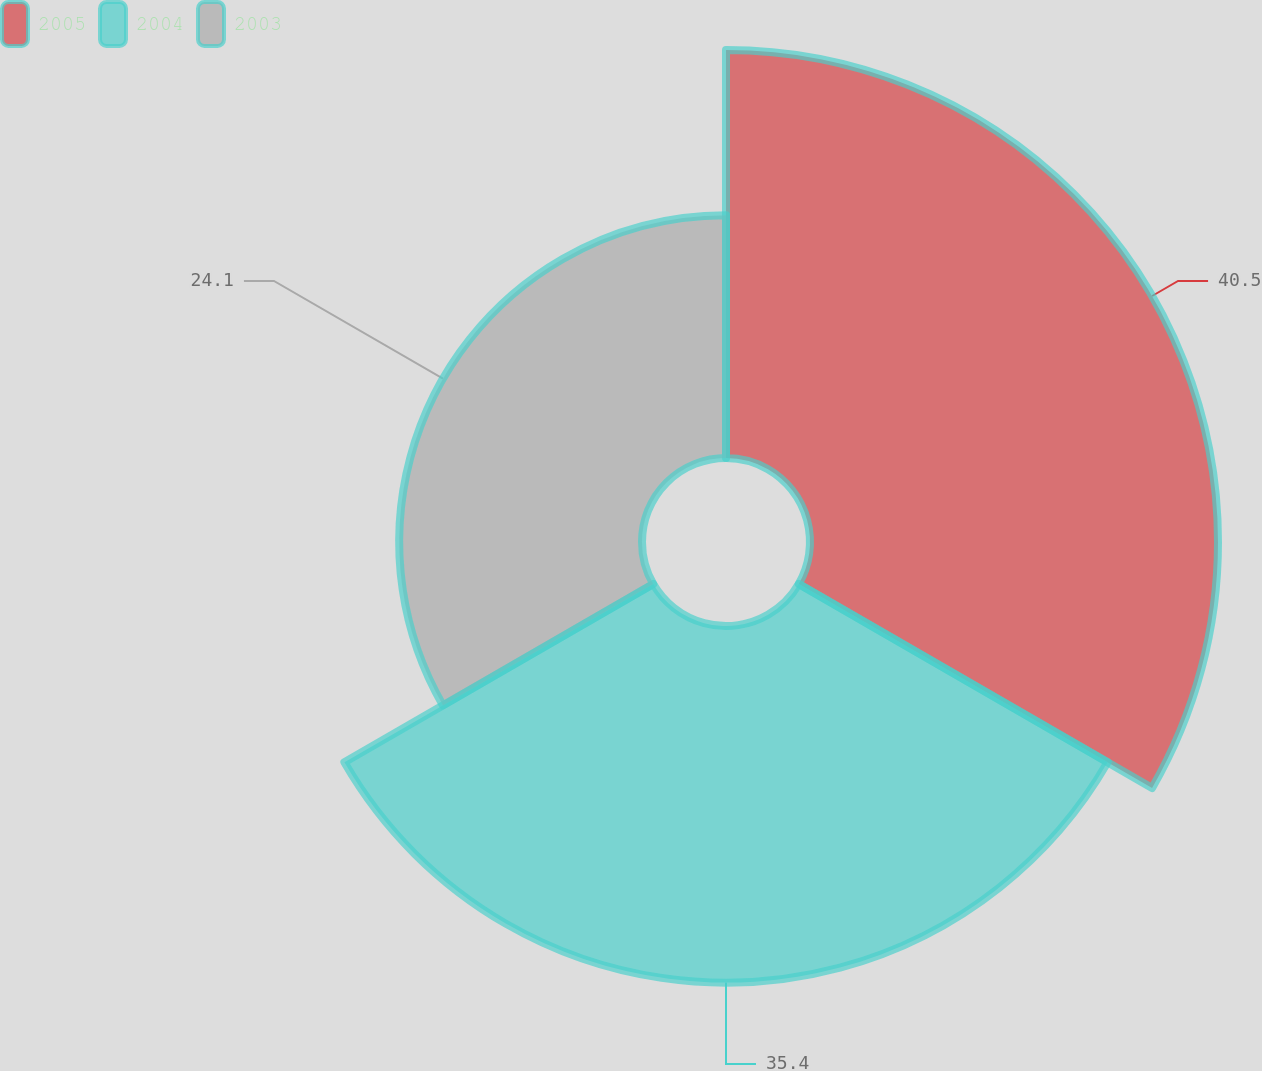Convert chart to OTSL. <chart><loc_0><loc_0><loc_500><loc_500><pie_chart><fcel>2005<fcel>2004<fcel>2003<nl><fcel>40.5%<fcel>35.4%<fcel>24.1%<nl></chart> 